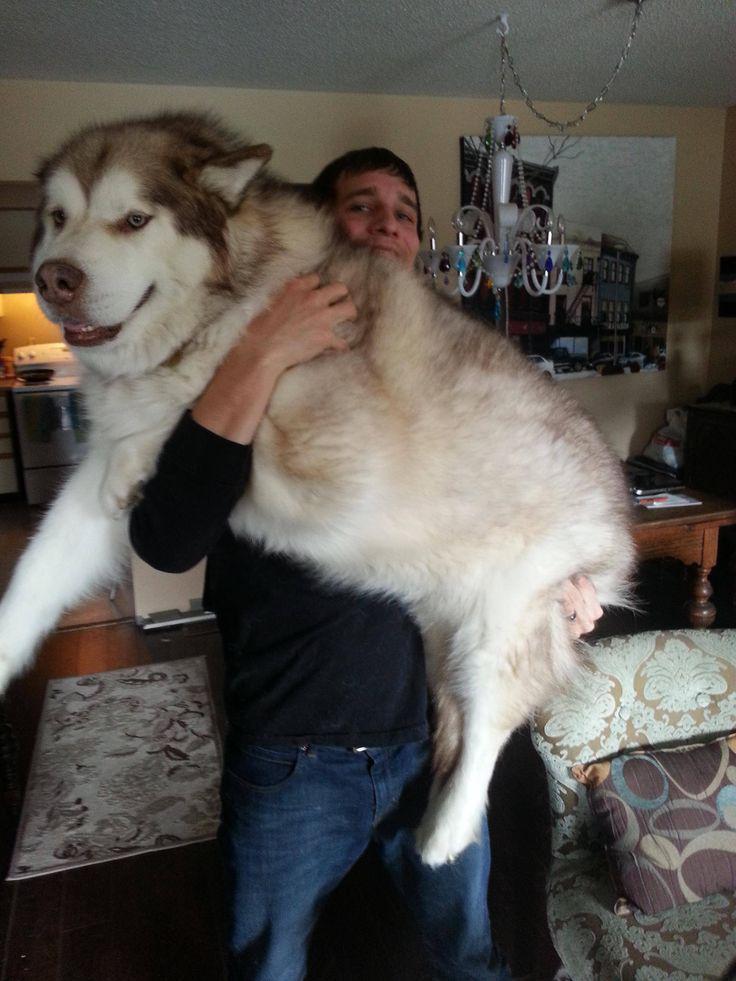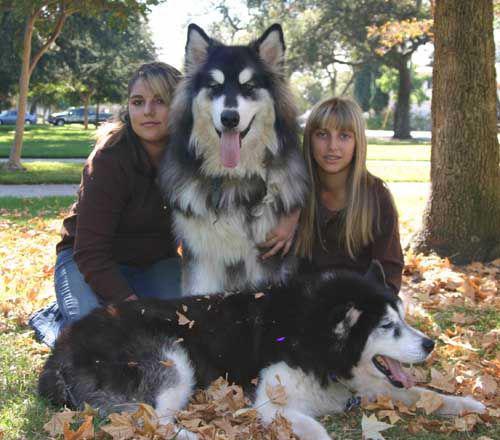The first image is the image on the left, the second image is the image on the right. Assess this claim about the two images: "In the right image, a little girl is hugging a big dog and laying the side of her head against it.". Correct or not? Answer yes or no. No. The first image is the image on the left, the second image is the image on the right. Given the left and right images, does the statement "The left and right image contains the same number of dogs." hold true? Answer yes or no. No. 